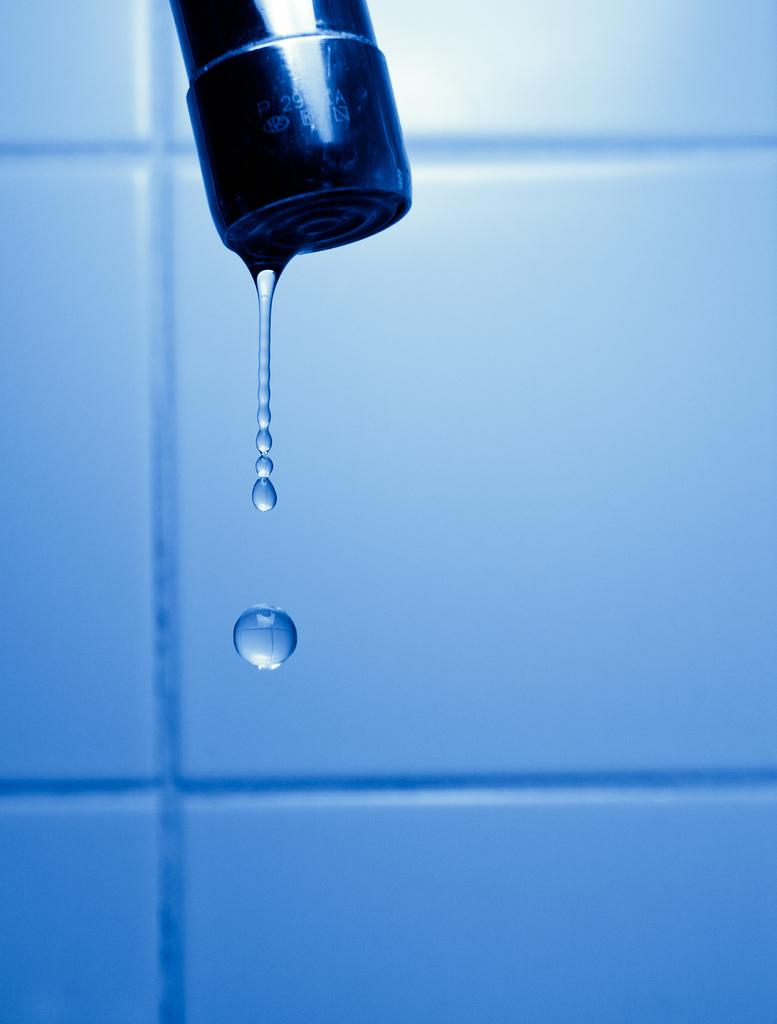What is the main object in the center of the image? There is a tap in the center of the image. What is the tap doing? Water droplets are coming out of the tap. What can be seen in the background of the image? There is a well in the background of the image. How many legs does the tap have in the image? Taps do not have legs; they are stationary objects. 